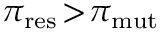<formula> <loc_0><loc_0><loc_500><loc_500>\pi _ { r e s } \, > \, \pi _ { m u t }</formula> 